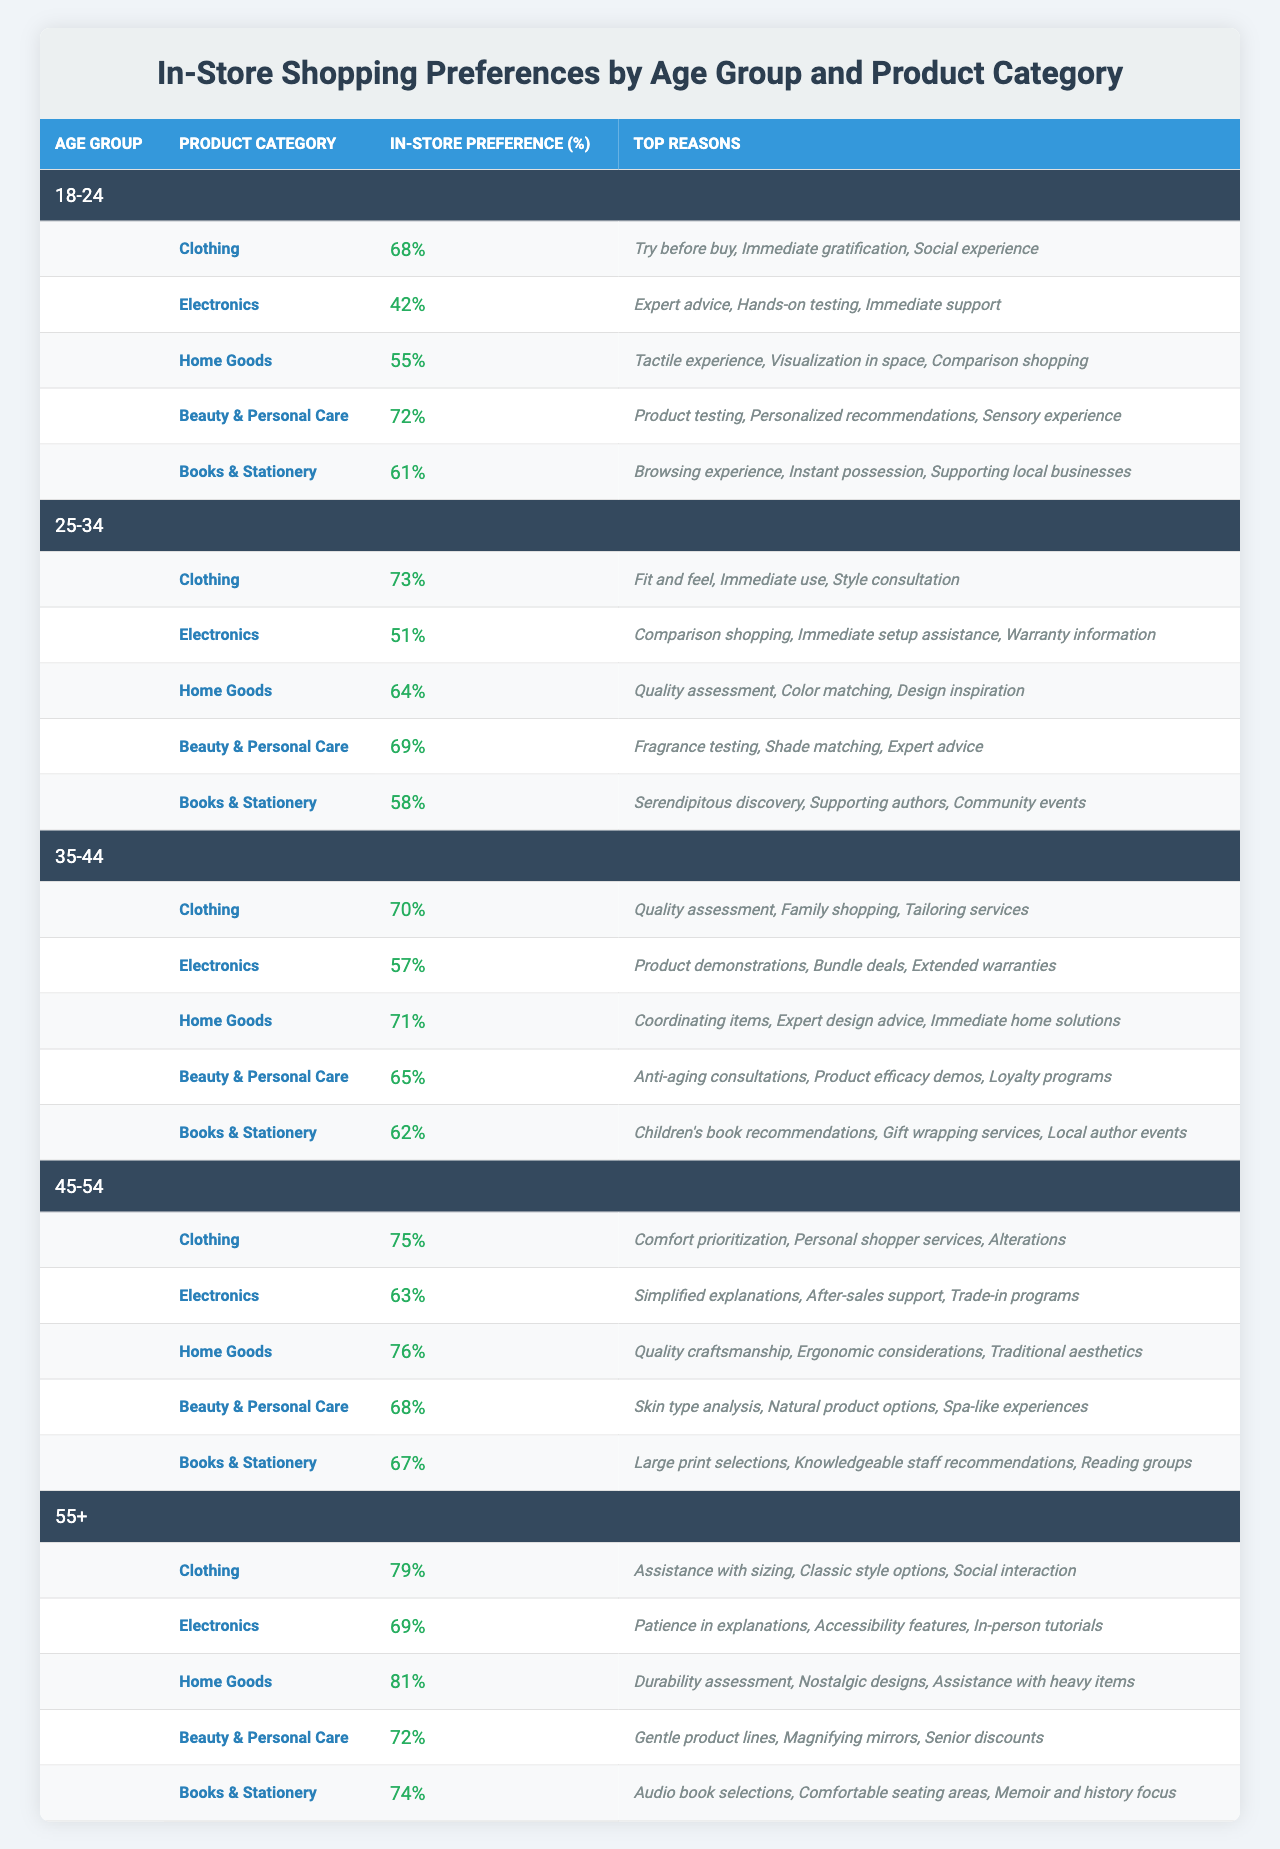What is the highest in-store preference for any product category among the age groups? The highest in-store preference is 81% for Home Goods in the 55+ age group.
Answer: 81% Which age group shows the least interest in in-store shopping for Electronics? The 18-24 age group shows the least interest with an in-store preference of 42%.
Answer: 42% What are the top reasons cited by the 25-34 age group for choosing in-store shopping for Beauty & Personal Care? The top reasons are fragrance testing, shade matching, and expert advice.
Answer: Fragrance testing, shade matching, expert advice Calculate the average in-store preference for Clothing across all age groups. The in-store preferences for Clothing are 68%, 73%, 70%, 75%, and 79%. Sum these values: 68 + 73 + 70 + 75 + 79 = 365. There are 5 age groups, so the average is 365/5 = 73%.
Answer: 73% Is there a noticeable trend in the in-store preference for Home Goods as the age group increases? Yes, the in-store preference for Home Goods increases from 55% in 18-24, to 81% in 55+, showing a clear upward trend.
Answer: Yes What is the in-store preference for Books & Stationery among the 45-54 age group, and what are its top reasons? The in-store preference for Books & Stationery is 67%, with top reasons being large print selections, knowledgeable staff recommendations, and reading groups.
Answer: 67%, large print selections, knowledgeable staff recommendations, reading groups Compare the in-store preferences for Electronics between the 35-44 and 55+ age groups. The 35-44 age group has a preference of 57%, while the 55+ age group has a preference of 69%. This shows that the older age group prefers in-store shopping for Electronics more.
Answer: 57% vs. 69% Which product category has the highest in-store preference among the 55+ age group? Home Goods has the highest preference at 81% among the 55+ age group.
Answer: 81% Do younger age groups prefer in-store shopping for Beauty & Personal Care more than older age groups? No, the 45-54 and 55+ age groups have higher preferences (68% and 72% respectively) compared to the younger groups.
Answer: No What is the total in-store preference for all product categories in the 18-24 age group? The in-store preferences for the 18-24 age group are: Clothing 68%, Electronics 42%, Home Goods 55%, Beauty & Personal Care 72%, and Books & Stationery 61%. The total is 68 + 42 + 55 + 72 + 61 = 298%.
Answer: 298% 